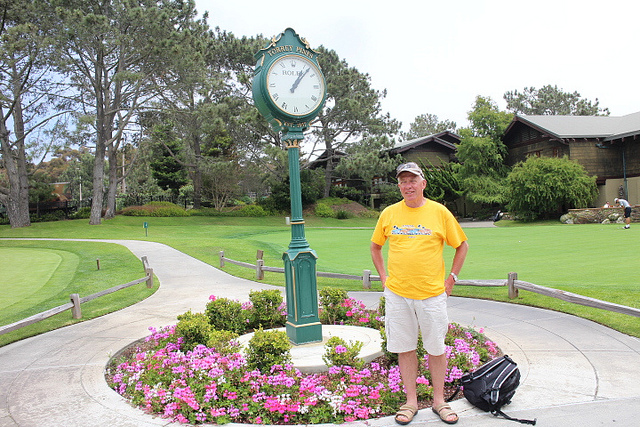Read all the text in this image. TORREV 